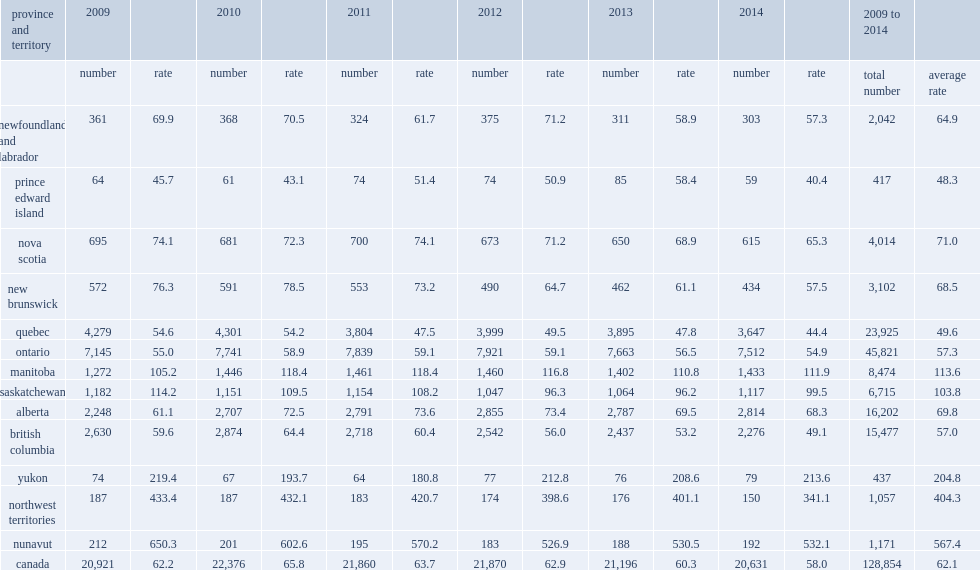Over the six-year period of study, what was the highest average annual rates of sexual assault reported in nunavut? 567.4. Over the six-year period of study, what was the average annual rates of sexual assault reported in the northwest territories? 404.3. Over the six-year period of study, what was the average annual rates of sexual assault were reported in yukon. 204.8. Over the six-year period of study,what was the sexual assault rates which were lowest in prince edward island? 48.3. Over the six-year period of study,what was the sexual assault rates in quebec? 49.6. Over the six-year period of study,what was the sexual assault rates in british columbia? 57.0. Over the six-year period of study,what was the sexual assault rates in ontario? 57.3. 